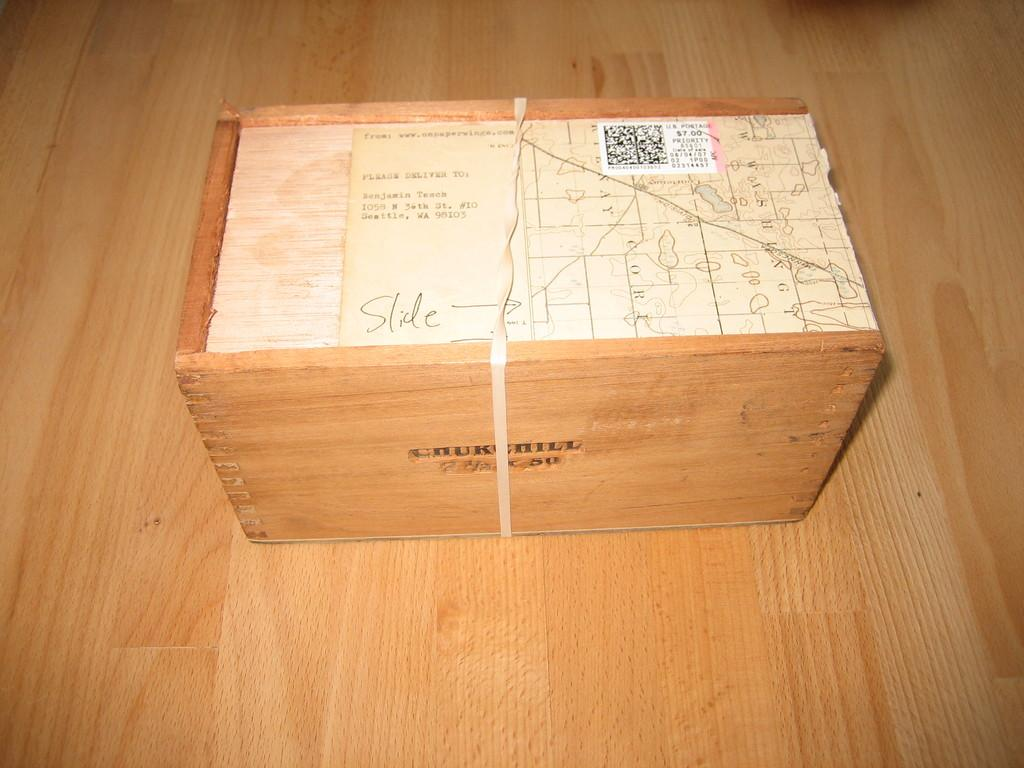<image>
Write a terse but informative summary of the picture. A postcard addressed to Benjamin sits on top of a wooden box/ 